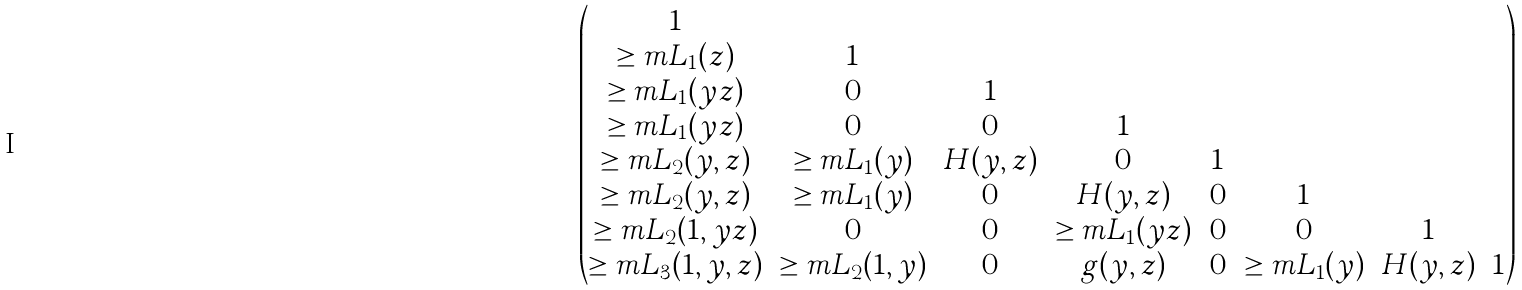<formula> <loc_0><loc_0><loc_500><loc_500>\begin{pmatrix} 1 & \ & \ & \ & \ & \ & \ & \ \\ \geq m L _ { 1 } ( z ) & 1 & \ & \ & \ & \ & \ & \ \\ \geq m L _ { 1 } ( y z ) & 0 & 1 & \ & \ & \ & \ & \ \\ \geq m L _ { 1 } ( y z ) & 0 & 0 & 1 & \ & \ & \ & \ \\ \geq m L _ { 2 } ( y , z ) & \geq m L _ { 1 } ( y ) & H ( y , z ) & 0 & 1 & \ & \ & \ \\ \geq m L _ { 2 } ( y , z ) & \geq m L _ { 1 } ( y ) & 0 & H ( y , z ) & 0 & 1 & \ & \ \\ \geq m L _ { 2 } ( 1 , y z ) & 0 & 0 & \geq m L _ { 1 } ( y z ) & 0 & 0 & 1 & \ \\ \geq m L _ { 3 } ( 1 , y , z ) & \geq m L _ { 2 } ( 1 , y ) & 0 & g ( y , z ) & 0 & \geq m L _ { 1 } ( y ) & H ( y , z ) & 1 \end{pmatrix}</formula> 